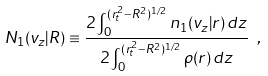<formula> <loc_0><loc_0><loc_500><loc_500>N _ { 1 } ( v _ { z } | R ) \equiv \frac { 2 \int _ { 0 } ^ { ( r _ { t } ^ { 2 } - R ^ { 2 } ) ^ { 1 / 2 } } n _ { 1 } ( v _ { z } | r ) \, d z } { 2 \int _ { 0 } ^ { ( r _ { t } ^ { 2 } - R ^ { 2 } ) ^ { 1 / 2 } } \rho ( r ) \, d z } \ ,</formula> 